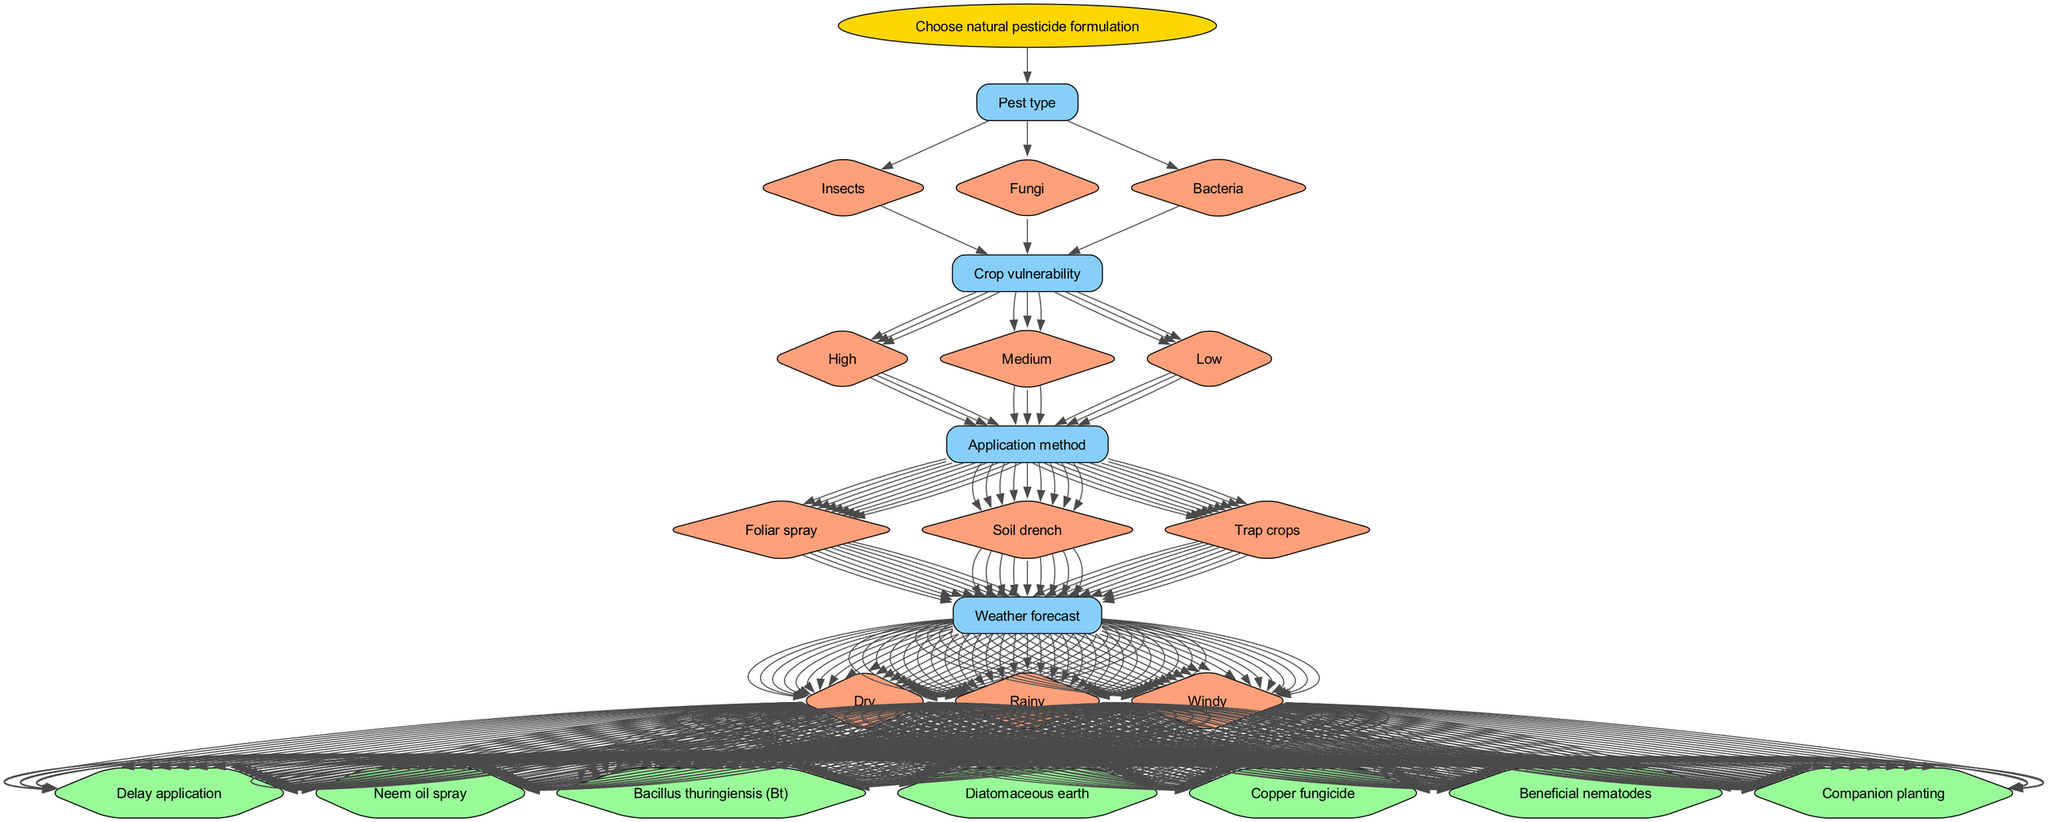What are the options for pest type? The options listed under the "Pest type" node in the diagram are "Insects", "Fungi", and "Bacteria".
Answer: Insects, Fungi, Bacteria How many outcomes are there in total? The diagram lists six outcomes, specifically: "Neem oil spray", "Bacillus thuringiensis (Bt)", "Diatomaceous earth", "Copper fungicide", "Beneficial nematodes", and "Companion planting" along with "Delay application".
Answer: Six What is the application method used if insects are the pest type and the weather is dry? To determine the application method, follow the path starting with "Pest type" being "Insects". After that, examine the decisions related to the application method, leading to choices that would directly relate to the given weather condition of "Dry". Thus, the method would be inferred accordingly.
Answer: It depends on further choices but could start with foliar spray Which pesticide is recommended for high crop vulnerability and rainy weather? First, identify that high crop vulnerability combined with rainy weather requires an application resistant to wash-off and effective against the identified pest. Following through the nodes towards outcomes, a suitable pesticide can be suggested.
Answer: Copper fungicide If the pest type is fungi and the crop vulnerability is low, what would be a reasonable pesticide decision? Begin at the "Pest type" and choose "Fungi", then move down to the vulnerability level of "Low", leading to decisions that typically would result in less aggressive treatments. Analyzing these leads to possibly less intensive outcomes, concluding with lower toxicity options.
Answer: Delay application What happens if I choose soil drench in a wet weather condition? Choosing the "Soil drench" application method while considering wet weather indicates a potential risk of dilution or runoff, which could hinder effectiveness. The decision tree reflects that certain pesticides may not perform optimally in these conditions.
Answer: Delay application 